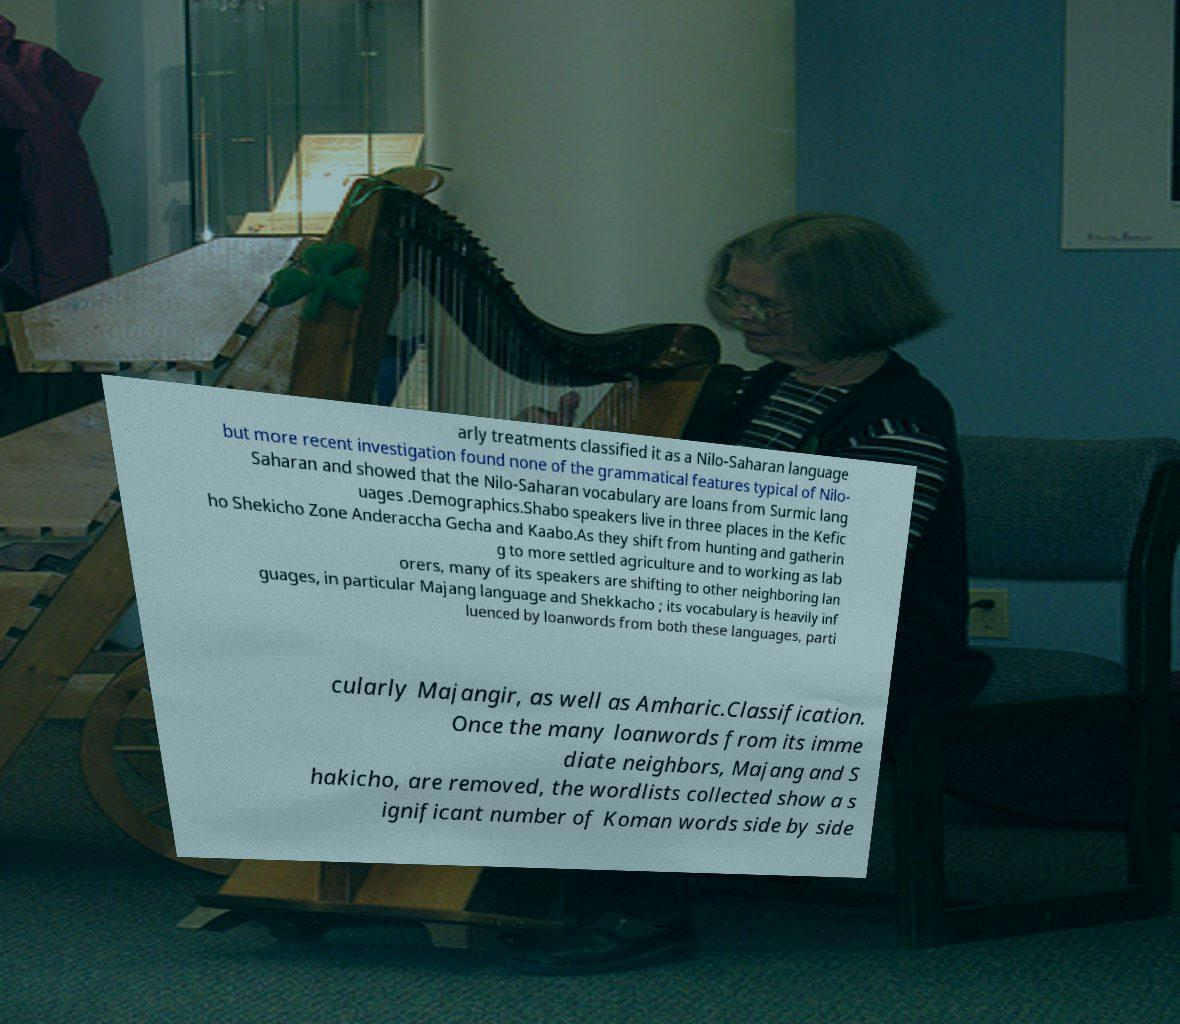Please read and relay the text visible in this image. What does it say? arly treatments classified it as a Nilo-Saharan language but more recent investigation found none of the grammatical features typical of Nilo- Saharan and showed that the Nilo-Saharan vocabulary are loans from Surmic lang uages .Demographics.Shabo speakers live in three places in the Kefic ho Shekicho Zone Anderaccha Gecha and Kaabo.As they shift from hunting and gatherin g to more settled agriculture and to working as lab orers, many of its speakers are shifting to other neighboring lan guages, in particular Majang language and Shekkacho ; its vocabulary is heavily inf luenced by loanwords from both these languages, parti cularly Majangir, as well as Amharic.Classification. Once the many loanwords from its imme diate neighbors, Majang and S hakicho, are removed, the wordlists collected show a s ignificant number of Koman words side by side 